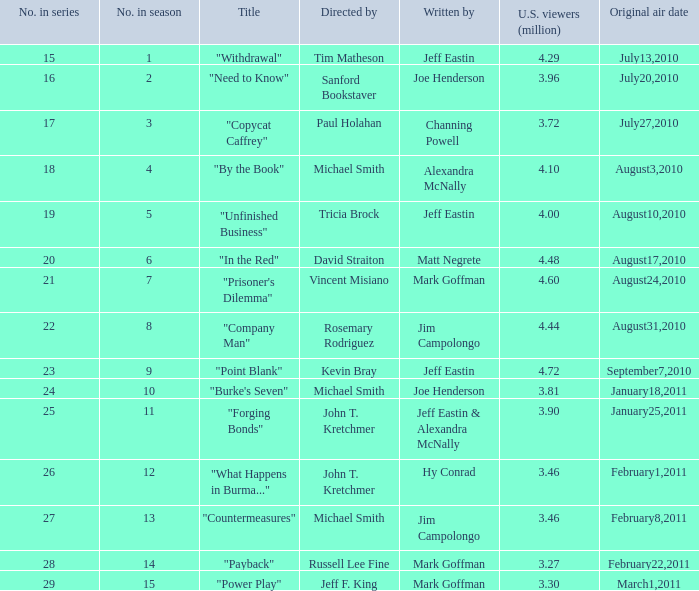How many episodes in the season had 3.81 million US viewers? 1.0. 